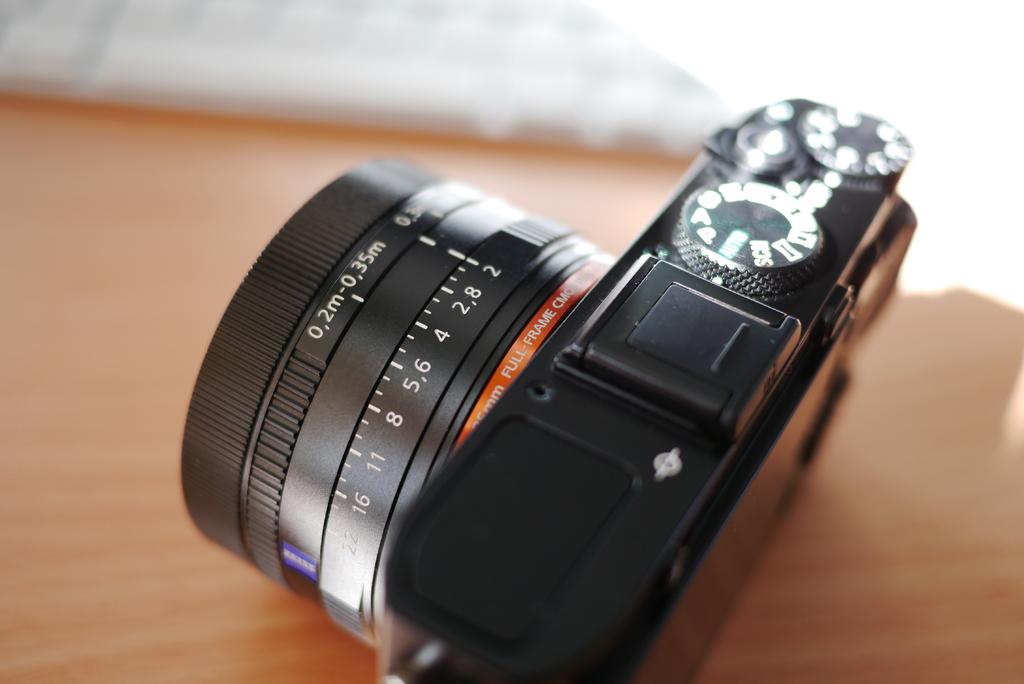What's the smallest in millimeters the lens goes?
Give a very brief answer. 0.2. 